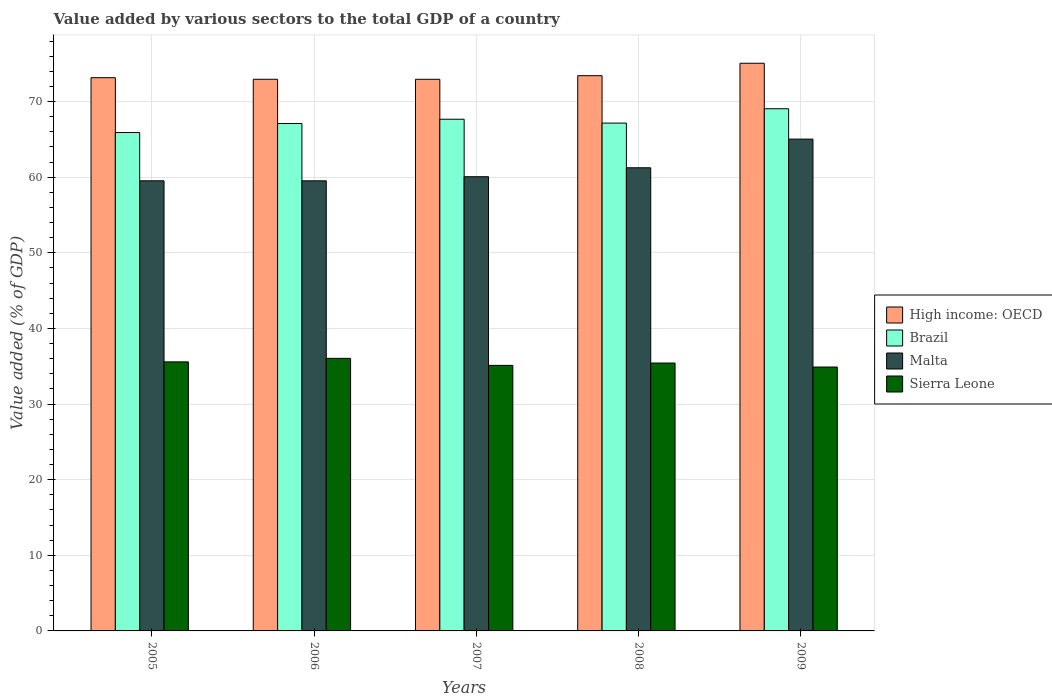How many different coloured bars are there?
Make the answer very short. 4. How many groups of bars are there?
Your response must be concise. 5. What is the label of the 1st group of bars from the left?
Offer a terse response. 2005. In how many cases, is the number of bars for a given year not equal to the number of legend labels?
Give a very brief answer. 0. What is the value added by various sectors to the total GDP in High income: OECD in 2008?
Give a very brief answer. 73.43. Across all years, what is the maximum value added by various sectors to the total GDP in High income: OECD?
Offer a terse response. 75.07. Across all years, what is the minimum value added by various sectors to the total GDP in Brazil?
Your response must be concise. 65.91. In which year was the value added by various sectors to the total GDP in Brazil maximum?
Offer a terse response. 2009. In which year was the value added by various sectors to the total GDP in Sierra Leone minimum?
Your answer should be very brief. 2009. What is the total value added by various sectors to the total GDP in Sierra Leone in the graph?
Your answer should be very brief. 177.07. What is the difference between the value added by various sectors to the total GDP in Sierra Leone in 2005 and that in 2007?
Give a very brief answer. 0.46. What is the difference between the value added by various sectors to the total GDP in Sierra Leone in 2009 and the value added by various sectors to the total GDP in Brazil in 2006?
Provide a short and direct response. -32.21. What is the average value added by various sectors to the total GDP in Brazil per year?
Your response must be concise. 67.38. In the year 2008, what is the difference between the value added by various sectors to the total GDP in Brazil and value added by various sectors to the total GDP in Malta?
Your answer should be very brief. 5.91. What is the ratio of the value added by various sectors to the total GDP in Malta in 2006 to that in 2008?
Your answer should be very brief. 0.97. What is the difference between the highest and the second highest value added by various sectors to the total GDP in High income: OECD?
Keep it short and to the point. 1.64. What is the difference between the highest and the lowest value added by various sectors to the total GDP in Brazil?
Provide a short and direct response. 3.15. In how many years, is the value added by various sectors to the total GDP in Malta greater than the average value added by various sectors to the total GDP in Malta taken over all years?
Provide a short and direct response. 2. Is it the case that in every year, the sum of the value added by various sectors to the total GDP in High income: OECD and value added by various sectors to the total GDP in Brazil is greater than the sum of value added by various sectors to the total GDP in Malta and value added by various sectors to the total GDP in Sierra Leone?
Your answer should be compact. Yes. What does the 4th bar from the left in 2009 represents?
Give a very brief answer. Sierra Leone. What does the 2nd bar from the right in 2008 represents?
Offer a terse response. Malta. How many bars are there?
Your response must be concise. 20. Does the graph contain any zero values?
Your response must be concise. No. Where does the legend appear in the graph?
Give a very brief answer. Center right. How are the legend labels stacked?
Your response must be concise. Vertical. What is the title of the graph?
Offer a very short reply. Value added by various sectors to the total GDP of a country. What is the label or title of the X-axis?
Your answer should be very brief. Years. What is the label or title of the Y-axis?
Give a very brief answer. Value added (% of GDP). What is the Value added (% of GDP) of High income: OECD in 2005?
Provide a short and direct response. 73.16. What is the Value added (% of GDP) of Brazil in 2005?
Offer a terse response. 65.91. What is the Value added (% of GDP) of Malta in 2005?
Give a very brief answer. 59.53. What is the Value added (% of GDP) of Sierra Leone in 2005?
Offer a very short reply. 35.58. What is the Value added (% of GDP) of High income: OECD in 2006?
Your answer should be compact. 72.96. What is the Value added (% of GDP) in Brazil in 2006?
Your answer should be very brief. 67.11. What is the Value added (% of GDP) in Malta in 2006?
Offer a terse response. 59.52. What is the Value added (% of GDP) in Sierra Leone in 2006?
Keep it short and to the point. 36.05. What is the Value added (% of GDP) of High income: OECD in 2007?
Keep it short and to the point. 72.95. What is the Value added (% of GDP) of Brazil in 2007?
Provide a succinct answer. 67.67. What is the Value added (% of GDP) of Malta in 2007?
Offer a very short reply. 60.07. What is the Value added (% of GDP) in Sierra Leone in 2007?
Make the answer very short. 35.12. What is the Value added (% of GDP) of High income: OECD in 2008?
Provide a short and direct response. 73.43. What is the Value added (% of GDP) in Brazil in 2008?
Keep it short and to the point. 67.16. What is the Value added (% of GDP) in Malta in 2008?
Give a very brief answer. 61.25. What is the Value added (% of GDP) of Sierra Leone in 2008?
Ensure brevity in your answer.  35.43. What is the Value added (% of GDP) in High income: OECD in 2009?
Ensure brevity in your answer.  75.07. What is the Value added (% of GDP) in Brazil in 2009?
Provide a succinct answer. 69.06. What is the Value added (% of GDP) in Malta in 2009?
Make the answer very short. 65.04. What is the Value added (% of GDP) of Sierra Leone in 2009?
Ensure brevity in your answer.  34.9. Across all years, what is the maximum Value added (% of GDP) in High income: OECD?
Ensure brevity in your answer.  75.07. Across all years, what is the maximum Value added (% of GDP) in Brazil?
Ensure brevity in your answer.  69.06. Across all years, what is the maximum Value added (% of GDP) in Malta?
Your response must be concise. 65.04. Across all years, what is the maximum Value added (% of GDP) in Sierra Leone?
Provide a short and direct response. 36.05. Across all years, what is the minimum Value added (% of GDP) of High income: OECD?
Offer a terse response. 72.95. Across all years, what is the minimum Value added (% of GDP) of Brazil?
Your answer should be very brief. 65.91. Across all years, what is the minimum Value added (% of GDP) of Malta?
Offer a very short reply. 59.52. Across all years, what is the minimum Value added (% of GDP) of Sierra Leone?
Make the answer very short. 34.9. What is the total Value added (% of GDP) of High income: OECD in the graph?
Offer a terse response. 367.58. What is the total Value added (% of GDP) in Brazil in the graph?
Give a very brief answer. 336.91. What is the total Value added (% of GDP) of Malta in the graph?
Keep it short and to the point. 305.41. What is the total Value added (% of GDP) in Sierra Leone in the graph?
Provide a succinct answer. 177.07. What is the difference between the Value added (% of GDP) of High income: OECD in 2005 and that in 2006?
Make the answer very short. 0.21. What is the difference between the Value added (% of GDP) in Brazil in 2005 and that in 2006?
Offer a very short reply. -1.19. What is the difference between the Value added (% of GDP) in Malta in 2005 and that in 2006?
Provide a succinct answer. 0. What is the difference between the Value added (% of GDP) of Sierra Leone in 2005 and that in 2006?
Your answer should be very brief. -0.47. What is the difference between the Value added (% of GDP) of High income: OECD in 2005 and that in 2007?
Your response must be concise. 0.21. What is the difference between the Value added (% of GDP) of Brazil in 2005 and that in 2007?
Your answer should be very brief. -1.76. What is the difference between the Value added (% of GDP) in Malta in 2005 and that in 2007?
Ensure brevity in your answer.  -0.54. What is the difference between the Value added (% of GDP) of Sierra Leone in 2005 and that in 2007?
Make the answer very short. 0.46. What is the difference between the Value added (% of GDP) of High income: OECD in 2005 and that in 2008?
Give a very brief answer. -0.27. What is the difference between the Value added (% of GDP) in Brazil in 2005 and that in 2008?
Your answer should be compact. -1.25. What is the difference between the Value added (% of GDP) in Malta in 2005 and that in 2008?
Your answer should be very brief. -1.72. What is the difference between the Value added (% of GDP) in Sierra Leone in 2005 and that in 2008?
Ensure brevity in your answer.  0.15. What is the difference between the Value added (% of GDP) in High income: OECD in 2005 and that in 2009?
Offer a very short reply. -1.91. What is the difference between the Value added (% of GDP) in Brazil in 2005 and that in 2009?
Provide a succinct answer. -3.15. What is the difference between the Value added (% of GDP) in Malta in 2005 and that in 2009?
Make the answer very short. -5.51. What is the difference between the Value added (% of GDP) of Sierra Leone in 2005 and that in 2009?
Ensure brevity in your answer.  0.68. What is the difference between the Value added (% of GDP) in High income: OECD in 2006 and that in 2007?
Keep it short and to the point. 0. What is the difference between the Value added (% of GDP) of Brazil in 2006 and that in 2007?
Provide a succinct answer. -0.57. What is the difference between the Value added (% of GDP) of Malta in 2006 and that in 2007?
Your response must be concise. -0.54. What is the difference between the Value added (% of GDP) in Sierra Leone in 2006 and that in 2007?
Your response must be concise. 0.93. What is the difference between the Value added (% of GDP) in High income: OECD in 2006 and that in 2008?
Provide a succinct answer. -0.48. What is the difference between the Value added (% of GDP) of Brazil in 2006 and that in 2008?
Offer a very short reply. -0.05. What is the difference between the Value added (% of GDP) in Malta in 2006 and that in 2008?
Offer a very short reply. -1.73. What is the difference between the Value added (% of GDP) in Sierra Leone in 2006 and that in 2008?
Offer a very short reply. 0.62. What is the difference between the Value added (% of GDP) of High income: OECD in 2006 and that in 2009?
Ensure brevity in your answer.  -2.12. What is the difference between the Value added (% of GDP) in Brazil in 2006 and that in 2009?
Provide a short and direct response. -1.95. What is the difference between the Value added (% of GDP) in Malta in 2006 and that in 2009?
Your answer should be very brief. -5.52. What is the difference between the Value added (% of GDP) of Sierra Leone in 2006 and that in 2009?
Your answer should be compact. 1.15. What is the difference between the Value added (% of GDP) of High income: OECD in 2007 and that in 2008?
Give a very brief answer. -0.48. What is the difference between the Value added (% of GDP) of Brazil in 2007 and that in 2008?
Provide a short and direct response. 0.51. What is the difference between the Value added (% of GDP) of Malta in 2007 and that in 2008?
Ensure brevity in your answer.  -1.18. What is the difference between the Value added (% of GDP) in Sierra Leone in 2007 and that in 2008?
Provide a succinct answer. -0.31. What is the difference between the Value added (% of GDP) in High income: OECD in 2007 and that in 2009?
Your answer should be compact. -2.12. What is the difference between the Value added (% of GDP) of Brazil in 2007 and that in 2009?
Give a very brief answer. -1.39. What is the difference between the Value added (% of GDP) in Malta in 2007 and that in 2009?
Provide a succinct answer. -4.97. What is the difference between the Value added (% of GDP) in Sierra Leone in 2007 and that in 2009?
Keep it short and to the point. 0.22. What is the difference between the Value added (% of GDP) in High income: OECD in 2008 and that in 2009?
Ensure brevity in your answer.  -1.64. What is the difference between the Value added (% of GDP) of Brazil in 2008 and that in 2009?
Your answer should be very brief. -1.9. What is the difference between the Value added (% of GDP) of Malta in 2008 and that in 2009?
Your response must be concise. -3.79. What is the difference between the Value added (% of GDP) in Sierra Leone in 2008 and that in 2009?
Provide a short and direct response. 0.53. What is the difference between the Value added (% of GDP) of High income: OECD in 2005 and the Value added (% of GDP) of Brazil in 2006?
Give a very brief answer. 6.06. What is the difference between the Value added (% of GDP) in High income: OECD in 2005 and the Value added (% of GDP) in Malta in 2006?
Provide a short and direct response. 13.64. What is the difference between the Value added (% of GDP) of High income: OECD in 2005 and the Value added (% of GDP) of Sierra Leone in 2006?
Give a very brief answer. 37.12. What is the difference between the Value added (% of GDP) in Brazil in 2005 and the Value added (% of GDP) in Malta in 2006?
Offer a terse response. 6.39. What is the difference between the Value added (% of GDP) of Brazil in 2005 and the Value added (% of GDP) of Sierra Leone in 2006?
Provide a succinct answer. 29.86. What is the difference between the Value added (% of GDP) of Malta in 2005 and the Value added (% of GDP) of Sierra Leone in 2006?
Give a very brief answer. 23.48. What is the difference between the Value added (% of GDP) of High income: OECD in 2005 and the Value added (% of GDP) of Brazil in 2007?
Give a very brief answer. 5.49. What is the difference between the Value added (% of GDP) of High income: OECD in 2005 and the Value added (% of GDP) of Malta in 2007?
Your answer should be very brief. 13.1. What is the difference between the Value added (% of GDP) in High income: OECD in 2005 and the Value added (% of GDP) in Sierra Leone in 2007?
Keep it short and to the point. 38.05. What is the difference between the Value added (% of GDP) in Brazil in 2005 and the Value added (% of GDP) in Malta in 2007?
Ensure brevity in your answer.  5.84. What is the difference between the Value added (% of GDP) of Brazil in 2005 and the Value added (% of GDP) of Sierra Leone in 2007?
Ensure brevity in your answer.  30.79. What is the difference between the Value added (% of GDP) of Malta in 2005 and the Value added (% of GDP) of Sierra Leone in 2007?
Your response must be concise. 24.41. What is the difference between the Value added (% of GDP) of High income: OECD in 2005 and the Value added (% of GDP) of Brazil in 2008?
Offer a very short reply. 6.01. What is the difference between the Value added (% of GDP) in High income: OECD in 2005 and the Value added (% of GDP) in Malta in 2008?
Your answer should be compact. 11.91. What is the difference between the Value added (% of GDP) in High income: OECD in 2005 and the Value added (% of GDP) in Sierra Leone in 2008?
Your answer should be very brief. 37.74. What is the difference between the Value added (% of GDP) of Brazil in 2005 and the Value added (% of GDP) of Malta in 2008?
Offer a very short reply. 4.66. What is the difference between the Value added (% of GDP) of Brazil in 2005 and the Value added (% of GDP) of Sierra Leone in 2008?
Offer a very short reply. 30.48. What is the difference between the Value added (% of GDP) in Malta in 2005 and the Value added (% of GDP) in Sierra Leone in 2008?
Your answer should be compact. 24.1. What is the difference between the Value added (% of GDP) of High income: OECD in 2005 and the Value added (% of GDP) of Brazil in 2009?
Give a very brief answer. 4.11. What is the difference between the Value added (% of GDP) of High income: OECD in 2005 and the Value added (% of GDP) of Malta in 2009?
Your answer should be very brief. 8.12. What is the difference between the Value added (% of GDP) in High income: OECD in 2005 and the Value added (% of GDP) in Sierra Leone in 2009?
Provide a succinct answer. 38.27. What is the difference between the Value added (% of GDP) of Brazil in 2005 and the Value added (% of GDP) of Malta in 2009?
Your response must be concise. 0.87. What is the difference between the Value added (% of GDP) of Brazil in 2005 and the Value added (% of GDP) of Sierra Leone in 2009?
Your answer should be very brief. 31.01. What is the difference between the Value added (% of GDP) of Malta in 2005 and the Value added (% of GDP) of Sierra Leone in 2009?
Give a very brief answer. 24.63. What is the difference between the Value added (% of GDP) of High income: OECD in 2006 and the Value added (% of GDP) of Brazil in 2007?
Keep it short and to the point. 5.28. What is the difference between the Value added (% of GDP) in High income: OECD in 2006 and the Value added (% of GDP) in Malta in 2007?
Provide a succinct answer. 12.89. What is the difference between the Value added (% of GDP) in High income: OECD in 2006 and the Value added (% of GDP) in Sierra Leone in 2007?
Provide a short and direct response. 37.84. What is the difference between the Value added (% of GDP) of Brazil in 2006 and the Value added (% of GDP) of Malta in 2007?
Provide a succinct answer. 7.04. What is the difference between the Value added (% of GDP) in Brazil in 2006 and the Value added (% of GDP) in Sierra Leone in 2007?
Your answer should be compact. 31.99. What is the difference between the Value added (% of GDP) of Malta in 2006 and the Value added (% of GDP) of Sierra Leone in 2007?
Your response must be concise. 24.41. What is the difference between the Value added (% of GDP) in High income: OECD in 2006 and the Value added (% of GDP) in Brazil in 2008?
Ensure brevity in your answer.  5.8. What is the difference between the Value added (% of GDP) in High income: OECD in 2006 and the Value added (% of GDP) in Malta in 2008?
Offer a very short reply. 11.7. What is the difference between the Value added (% of GDP) in High income: OECD in 2006 and the Value added (% of GDP) in Sierra Leone in 2008?
Your answer should be compact. 37.53. What is the difference between the Value added (% of GDP) of Brazil in 2006 and the Value added (% of GDP) of Malta in 2008?
Give a very brief answer. 5.85. What is the difference between the Value added (% of GDP) in Brazil in 2006 and the Value added (% of GDP) in Sierra Leone in 2008?
Offer a terse response. 31.68. What is the difference between the Value added (% of GDP) of Malta in 2006 and the Value added (% of GDP) of Sierra Leone in 2008?
Give a very brief answer. 24.1. What is the difference between the Value added (% of GDP) in High income: OECD in 2006 and the Value added (% of GDP) in Brazil in 2009?
Keep it short and to the point. 3.9. What is the difference between the Value added (% of GDP) in High income: OECD in 2006 and the Value added (% of GDP) in Malta in 2009?
Your answer should be very brief. 7.91. What is the difference between the Value added (% of GDP) in High income: OECD in 2006 and the Value added (% of GDP) in Sierra Leone in 2009?
Ensure brevity in your answer.  38.06. What is the difference between the Value added (% of GDP) in Brazil in 2006 and the Value added (% of GDP) in Malta in 2009?
Provide a short and direct response. 2.06. What is the difference between the Value added (% of GDP) of Brazil in 2006 and the Value added (% of GDP) of Sierra Leone in 2009?
Offer a very short reply. 32.21. What is the difference between the Value added (% of GDP) of Malta in 2006 and the Value added (% of GDP) of Sierra Leone in 2009?
Keep it short and to the point. 24.63. What is the difference between the Value added (% of GDP) of High income: OECD in 2007 and the Value added (% of GDP) of Brazil in 2008?
Offer a very short reply. 5.79. What is the difference between the Value added (% of GDP) of High income: OECD in 2007 and the Value added (% of GDP) of Malta in 2008?
Your answer should be very brief. 11.7. What is the difference between the Value added (% of GDP) of High income: OECD in 2007 and the Value added (% of GDP) of Sierra Leone in 2008?
Offer a terse response. 37.52. What is the difference between the Value added (% of GDP) of Brazil in 2007 and the Value added (% of GDP) of Malta in 2008?
Offer a very short reply. 6.42. What is the difference between the Value added (% of GDP) in Brazil in 2007 and the Value added (% of GDP) in Sierra Leone in 2008?
Keep it short and to the point. 32.24. What is the difference between the Value added (% of GDP) in Malta in 2007 and the Value added (% of GDP) in Sierra Leone in 2008?
Keep it short and to the point. 24.64. What is the difference between the Value added (% of GDP) in High income: OECD in 2007 and the Value added (% of GDP) in Brazil in 2009?
Keep it short and to the point. 3.89. What is the difference between the Value added (% of GDP) in High income: OECD in 2007 and the Value added (% of GDP) in Malta in 2009?
Provide a succinct answer. 7.91. What is the difference between the Value added (% of GDP) in High income: OECD in 2007 and the Value added (% of GDP) in Sierra Leone in 2009?
Make the answer very short. 38.05. What is the difference between the Value added (% of GDP) of Brazil in 2007 and the Value added (% of GDP) of Malta in 2009?
Give a very brief answer. 2.63. What is the difference between the Value added (% of GDP) in Brazil in 2007 and the Value added (% of GDP) in Sierra Leone in 2009?
Make the answer very short. 32.77. What is the difference between the Value added (% of GDP) in Malta in 2007 and the Value added (% of GDP) in Sierra Leone in 2009?
Your answer should be compact. 25.17. What is the difference between the Value added (% of GDP) in High income: OECD in 2008 and the Value added (% of GDP) in Brazil in 2009?
Provide a succinct answer. 4.37. What is the difference between the Value added (% of GDP) of High income: OECD in 2008 and the Value added (% of GDP) of Malta in 2009?
Offer a very short reply. 8.39. What is the difference between the Value added (% of GDP) of High income: OECD in 2008 and the Value added (% of GDP) of Sierra Leone in 2009?
Offer a terse response. 38.53. What is the difference between the Value added (% of GDP) in Brazil in 2008 and the Value added (% of GDP) in Malta in 2009?
Your answer should be very brief. 2.12. What is the difference between the Value added (% of GDP) of Brazil in 2008 and the Value added (% of GDP) of Sierra Leone in 2009?
Keep it short and to the point. 32.26. What is the difference between the Value added (% of GDP) of Malta in 2008 and the Value added (% of GDP) of Sierra Leone in 2009?
Make the answer very short. 26.35. What is the average Value added (% of GDP) of High income: OECD per year?
Offer a very short reply. 73.52. What is the average Value added (% of GDP) of Brazil per year?
Keep it short and to the point. 67.38. What is the average Value added (% of GDP) of Malta per year?
Your response must be concise. 61.08. What is the average Value added (% of GDP) in Sierra Leone per year?
Your answer should be very brief. 35.41. In the year 2005, what is the difference between the Value added (% of GDP) of High income: OECD and Value added (% of GDP) of Brazil?
Make the answer very short. 7.25. In the year 2005, what is the difference between the Value added (% of GDP) of High income: OECD and Value added (% of GDP) of Malta?
Your answer should be very brief. 13.64. In the year 2005, what is the difference between the Value added (% of GDP) of High income: OECD and Value added (% of GDP) of Sierra Leone?
Your answer should be compact. 37.58. In the year 2005, what is the difference between the Value added (% of GDP) of Brazil and Value added (% of GDP) of Malta?
Make the answer very short. 6.38. In the year 2005, what is the difference between the Value added (% of GDP) of Brazil and Value added (% of GDP) of Sierra Leone?
Keep it short and to the point. 30.33. In the year 2005, what is the difference between the Value added (% of GDP) in Malta and Value added (% of GDP) in Sierra Leone?
Give a very brief answer. 23.95. In the year 2006, what is the difference between the Value added (% of GDP) in High income: OECD and Value added (% of GDP) in Brazil?
Your response must be concise. 5.85. In the year 2006, what is the difference between the Value added (% of GDP) of High income: OECD and Value added (% of GDP) of Malta?
Give a very brief answer. 13.43. In the year 2006, what is the difference between the Value added (% of GDP) of High income: OECD and Value added (% of GDP) of Sierra Leone?
Give a very brief answer. 36.91. In the year 2006, what is the difference between the Value added (% of GDP) of Brazil and Value added (% of GDP) of Malta?
Provide a short and direct response. 7.58. In the year 2006, what is the difference between the Value added (% of GDP) in Brazil and Value added (% of GDP) in Sierra Leone?
Provide a succinct answer. 31.06. In the year 2006, what is the difference between the Value added (% of GDP) in Malta and Value added (% of GDP) in Sierra Leone?
Give a very brief answer. 23.48. In the year 2007, what is the difference between the Value added (% of GDP) in High income: OECD and Value added (% of GDP) in Brazil?
Make the answer very short. 5.28. In the year 2007, what is the difference between the Value added (% of GDP) in High income: OECD and Value added (% of GDP) in Malta?
Give a very brief answer. 12.88. In the year 2007, what is the difference between the Value added (% of GDP) of High income: OECD and Value added (% of GDP) of Sierra Leone?
Provide a succinct answer. 37.83. In the year 2007, what is the difference between the Value added (% of GDP) in Brazil and Value added (% of GDP) in Malta?
Provide a short and direct response. 7.6. In the year 2007, what is the difference between the Value added (% of GDP) in Brazil and Value added (% of GDP) in Sierra Leone?
Offer a very short reply. 32.55. In the year 2007, what is the difference between the Value added (% of GDP) in Malta and Value added (% of GDP) in Sierra Leone?
Offer a terse response. 24.95. In the year 2008, what is the difference between the Value added (% of GDP) in High income: OECD and Value added (% of GDP) in Brazil?
Give a very brief answer. 6.27. In the year 2008, what is the difference between the Value added (% of GDP) of High income: OECD and Value added (% of GDP) of Malta?
Your answer should be compact. 12.18. In the year 2008, what is the difference between the Value added (% of GDP) of High income: OECD and Value added (% of GDP) of Sierra Leone?
Your answer should be very brief. 38. In the year 2008, what is the difference between the Value added (% of GDP) of Brazil and Value added (% of GDP) of Malta?
Offer a very short reply. 5.91. In the year 2008, what is the difference between the Value added (% of GDP) of Brazil and Value added (% of GDP) of Sierra Leone?
Offer a very short reply. 31.73. In the year 2008, what is the difference between the Value added (% of GDP) in Malta and Value added (% of GDP) in Sierra Leone?
Provide a succinct answer. 25.82. In the year 2009, what is the difference between the Value added (% of GDP) in High income: OECD and Value added (% of GDP) in Brazil?
Make the answer very short. 6.01. In the year 2009, what is the difference between the Value added (% of GDP) in High income: OECD and Value added (% of GDP) in Malta?
Give a very brief answer. 10.03. In the year 2009, what is the difference between the Value added (% of GDP) of High income: OECD and Value added (% of GDP) of Sierra Leone?
Your answer should be compact. 40.17. In the year 2009, what is the difference between the Value added (% of GDP) of Brazil and Value added (% of GDP) of Malta?
Your response must be concise. 4.02. In the year 2009, what is the difference between the Value added (% of GDP) in Brazil and Value added (% of GDP) in Sierra Leone?
Keep it short and to the point. 34.16. In the year 2009, what is the difference between the Value added (% of GDP) of Malta and Value added (% of GDP) of Sierra Leone?
Offer a very short reply. 30.14. What is the ratio of the Value added (% of GDP) of Brazil in 2005 to that in 2006?
Your answer should be very brief. 0.98. What is the ratio of the Value added (% of GDP) of Malta in 2005 to that in 2006?
Provide a short and direct response. 1. What is the ratio of the Value added (% of GDP) in Sierra Leone in 2005 to that in 2006?
Offer a terse response. 0.99. What is the ratio of the Value added (% of GDP) in High income: OECD in 2005 to that in 2007?
Keep it short and to the point. 1. What is the ratio of the Value added (% of GDP) of Malta in 2005 to that in 2007?
Offer a very short reply. 0.99. What is the ratio of the Value added (% of GDP) of Sierra Leone in 2005 to that in 2007?
Make the answer very short. 1.01. What is the ratio of the Value added (% of GDP) in High income: OECD in 2005 to that in 2008?
Keep it short and to the point. 1. What is the ratio of the Value added (% of GDP) of Brazil in 2005 to that in 2008?
Offer a terse response. 0.98. What is the ratio of the Value added (% of GDP) of Malta in 2005 to that in 2008?
Make the answer very short. 0.97. What is the ratio of the Value added (% of GDP) in Sierra Leone in 2005 to that in 2008?
Offer a terse response. 1. What is the ratio of the Value added (% of GDP) of High income: OECD in 2005 to that in 2009?
Your response must be concise. 0.97. What is the ratio of the Value added (% of GDP) in Brazil in 2005 to that in 2009?
Provide a short and direct response. 0.95. What is the ratio of the Value added (% of GDP) in Malta in 2005 to that in 2009?
Offer a terse response. 0.92. What is the ratio of the Value added (% of GDP) in Sierra Leone in 2005 to that in 2009?
Your answer should be compact. 1.02. What is the ratio of the Value added (% of GDP) in High income: OECD in 2006 to that in 2007?
Offer a very short reply. 1. What is the ratio of the Value added (% of GDP) in Brazil in 2006 to that in 2007?
Make the answer very short. 0.99. What is the ratio of the Value added (% of GDP) in Malta in 2006 to that in 2007?
Offer a very short reply. 0.99. What is the ratio of the Value added (% of GDP) in Sierra Leone in 2006 to that in 2007?
Keep it short and to the point. 1.03. What is the ratio of the Value added (% of GDP) in Malta in 2006 to that in 2008?
Your answer should be very brief. 0.97. What is the ratio of the Value added (% of GDP) in Sierra Leone in 2006 to that in 2008?
Provide a succinct answer. 1.02. What is the ratio of the Value added (% of GDP) in High income: OECD in 2006 to that in 2009?
Offer a very short reply. 0.97. What is the ratio of the Value added (% of GDP) of Brazil in 2006 to that in 2009?
Offer a very short reply. 0.97. What is the ratio of the Value added (% of GDP) in Malta in 2006 to that in 2009?
Provide a short and direct response. 0.92. What is the ratio of the Value added (% of GDP) in Sierra Leone in 2006 to that in 2009?
Offer a very short reply. 1.03. What is the ratio of the Value added (% of GDP) of High income: OECD in 2007 to that in 2008?
Keep it short and to the point. 0.99. What is the ratio of the Value added (% of GDP) in Brazil in 2007 to that in 2008?
Your answer should be very brief. 1.01. What is the ratio of the Value added (% of GDP) in Malta in 2007 to that in 2008?
Your response must be concise. 0.98. What is the ratio of the Value added (% of GDP) in High income: OECD in 2007 to that in 2009?
Provide a succinct answer. 0.97. What is the ratio of the Value added (% of GDP) of Brazil in 2007 to that in 2009?
Give a very brief answer. 0.98. What is the ratio of the Value added (% of GDP) of Malta in 2007 to that in 2009?
Provide a succinct answer. 0.92. What is the ratio of the Value added (% of GDP) in Sierra Leone in 2007 to that in 2009?
Offer a very short reply. 1.01. What is the ratio of the Value added (% of GDP) of High income: OECD in 2008 to that in 2009?
Make the answer very short. 0.98. What is the ratio of the Value added (% of GDP) in Brazil in 2008 to that in 2009?
Your answer should be compact. 0.97. What is the ratio of the Value added (% of GDP) in Malta in 2008 to that in 2009?
Your response must be concise. 0.94. What is the ratio of the Value added (% of GDP) of Sierra Leone in 2008 to that in 2009?
Give a very brief answer. 1.02. What is the difference between the highest and the second highest Value added (% of GDP) of High income: OECD?
Ensure brevity in your answer.  1.64. What is the difference between the highest and the second highest Value added (% of GDP) of Brazil?
Your response must be concise. 1.39. What is the difference between the highest and the second highest Value added (% of GDP) of Malta?
Provide a succinct answer. 3.79. What is the difference between the highest and the second highest Value added (% of GDP) in Sierra Leone?
Provide a short and direct response. 0.47. What is the difference between the highest and the lowest Value added (% of GDP) of High income: OECD?
Make the answer very short. 2.12. What is the difference between the highest and the lowest Value added (% of GDP) in Brazil?
Provide a short and direct response. 3.15. What is the difference between the highest and the lowest Value added (% of GDP) in Malta?
Offer a very short reply. 5.52. What is the difference between the highest and the lowest Value added (% of GDP) of Sierra Leone?
Offer a very short reply. 1.15. 